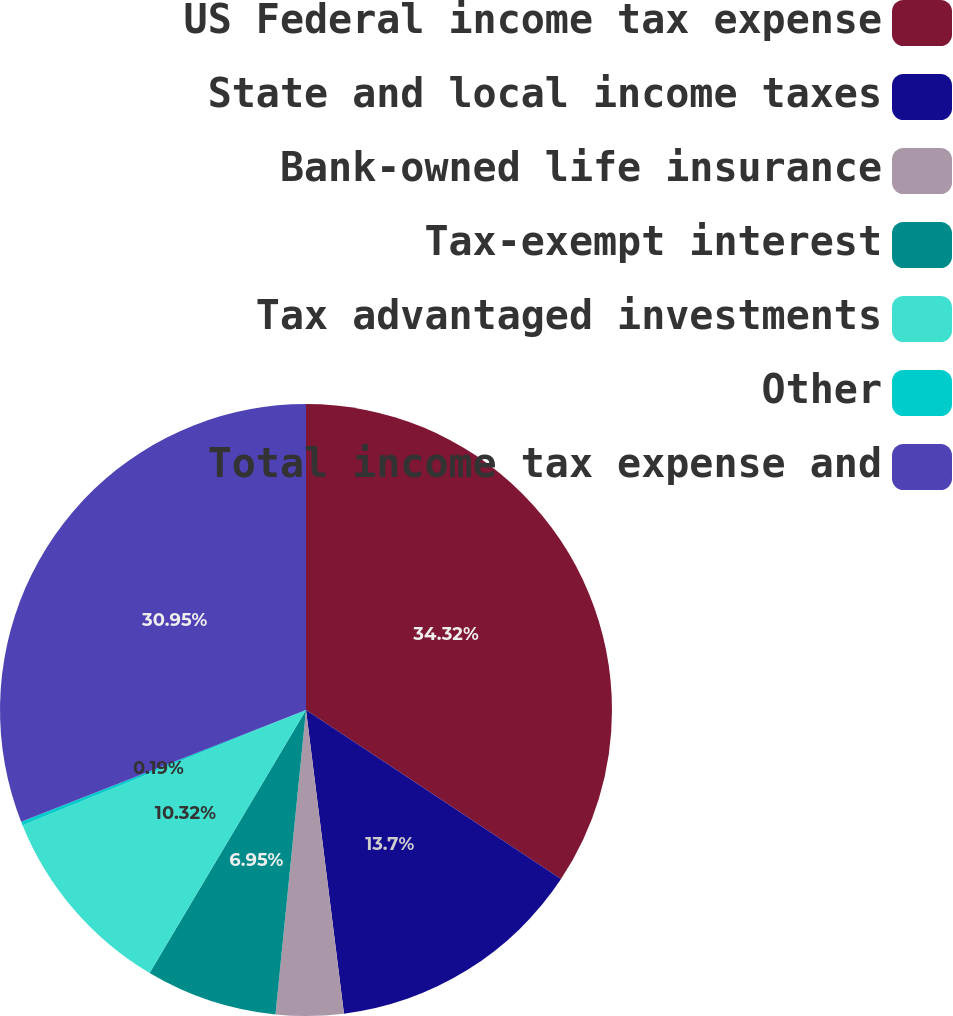Convert chart. <chart><loc_0><loc_0><loc_500><loc_500><pie_chart><fcel>US Federal income tax expense<fcel>State and local income taxes<fcel>Bank-owned life insurance<fcel>Tax-exempt interest<fcel>Tax advantaged investments<fcel>Other<fcel>Total income tax expense and<nl><fcel>34.32%<fcel>13.7%<fcel>3.57%<fcel>6.95%<fcel>10.32%<fcel>0.19%<fcel>30.95%<nl></chart> 